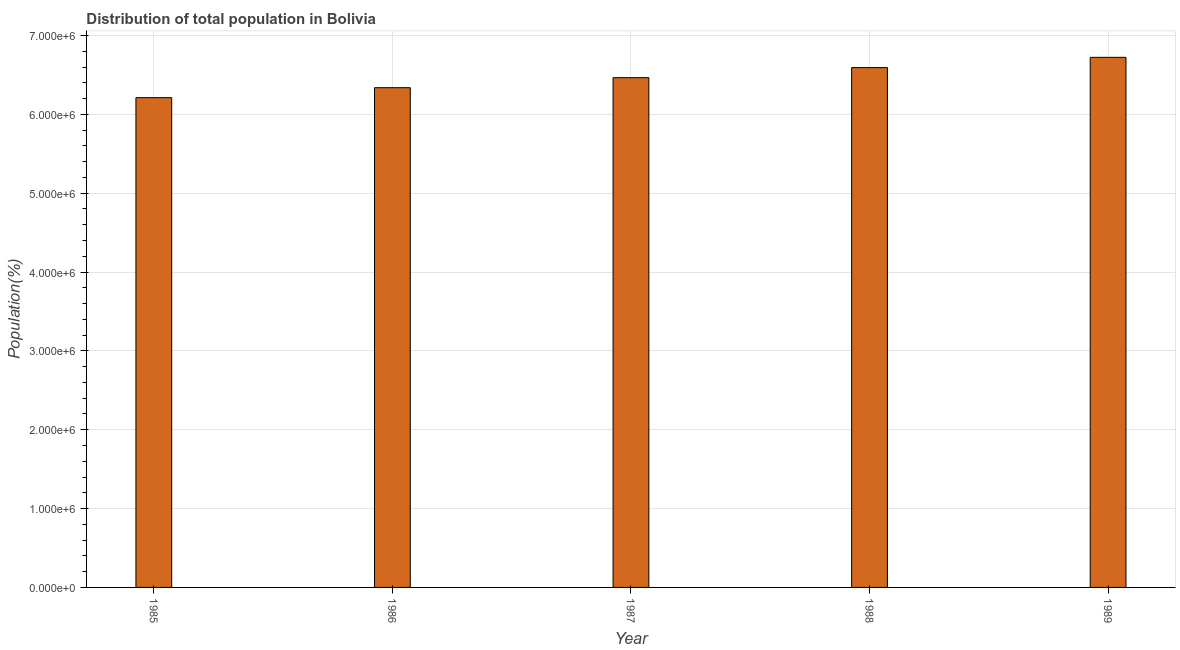What is the title of the graph?
Offer a very short reply. Distribution of total population in Bolivia . What is the label or title of the Y-axis?
Your answer should be compact. Population(%). What is the population in 1986?
Provide a succinct answer. 6.34e+06. Across all years, what is the maximum population?
Your answer should be very brief. 6.72e+06. Across all years, what is the minimum population?
Ensure brevity in your answer.  6.21e+06. In which year was the population minimum?
Keep it short and to the point. 1985. What is the sum of the population?
Offer a terse response. 3.23e+07. What is the difference between the population in 1985 and 1987?
Give a very brief answer. -2.53e+05. What is the average population per year?
Your answer should be compact. 6.47e+06. What is the median population?
Your response must be concise. 6.46e+06. In how many years, is the population greater than 2200000 %?
Your response must be concise. 5. What is the ratio of the population in 1985 to that in 1988?
Provide a short and direct response. 0.94. What is the difference between the highest and the second highest population?
Provide a short and direct response. 1.30e+05. Is the sum of the population in 1987 and 1988 greater than the maximum population across all years?
Make the answer very short. Yes. What is the difference between the highest and the lowest population?
Keep it short and to the point. 5.11e+05. How many years are there in the graph?
Make the answer very short. 5. What is the difference between two consecutive major ticks on the Y-axis?
Make the answer very short. 1.00e+06. Are the values on the major ticks of Y-axis written in scientific E-notation?
Your answer should be very brief. Yes. What is the Population(%) in 1985?
Make the answer very short. 6.21e+06. What is the Population(%) in 1986?
Offer a terse response. 6.34e+06. What is the Population(%) in 1987?
Ensure brevity in your answer.  6.46e+06. What is the Population(%) in 1988?
Give a very brief answer. 6.59e+06. What is the Population(%) of 1989?
Offer a terse response. 6.72e+06. What is the difference between the Population(%) in 1985 and 1986?
Make the answer very short. -1.26e+05. What is the difference between the Population(%) in 1985 and 1987?
Your answer should be compact. -2.53e+05. What is the difference between the Population(%) in 1985 and 1988?
Offer a very short reply. -3.81e+05. What is the difference between the Population(%) in 1985 and 1989?
Provide a short and direct response. -5.11e+05. What is the difference between the Population(%) in 1986 and 1987?
Give a very brief answer. -1.27e+05. What is the difference between the Population(%) in 1986 and 1988?
Keep it short and to the point. -2.55e+05. What is the difference between the Population(%) in 1986 and 1989?
Keep it short and to the point. -3.85e+05. What is the difference between the Population(%) in 1987 and 1988?
Your response must be concise. -1.28e+05. What is the difference between the Population(%) in 1987 and 1989?
Keep it short and to the point. -2.58e+05. What is the difference between the Population(%) in 1988 and 1989?
Provide a succinct answer. -1.30e+05. What is the ratio of the Population(%) in 1985 to that in 1988?
Offer a very short reply. 0.94. What is the ratio of the Population(%) in 1985 to that in 1989?
Make the answer very short. 0.92. What is the ratio of the Population(%) in 1986 to that in 1987?
Keep it short and to the point. 0.98. What is the ratio of the Population(%) in 1986 to that in 1988?
Give a very brief answer. 0.96. What is the ratio of the Population(%) in 1986 to that in 1989?
Your answer should be compact. 0.94. What is the ratio of the Population(%) in 1987 to that in 1989?
Provide a succinct answer. 0.96. 